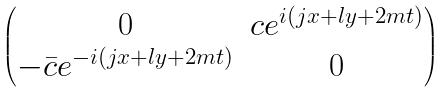<formula> <loc_0><loc_0><loc_500><loc_500>\begin{pmatrix} 0 & c e ^ { i ( j x + l y + 2 m t ) } \\ - \bar { c } e ^ { - i ( j x + l y + 2 m t ) } & 0 \end{pmatrix}</formula> 